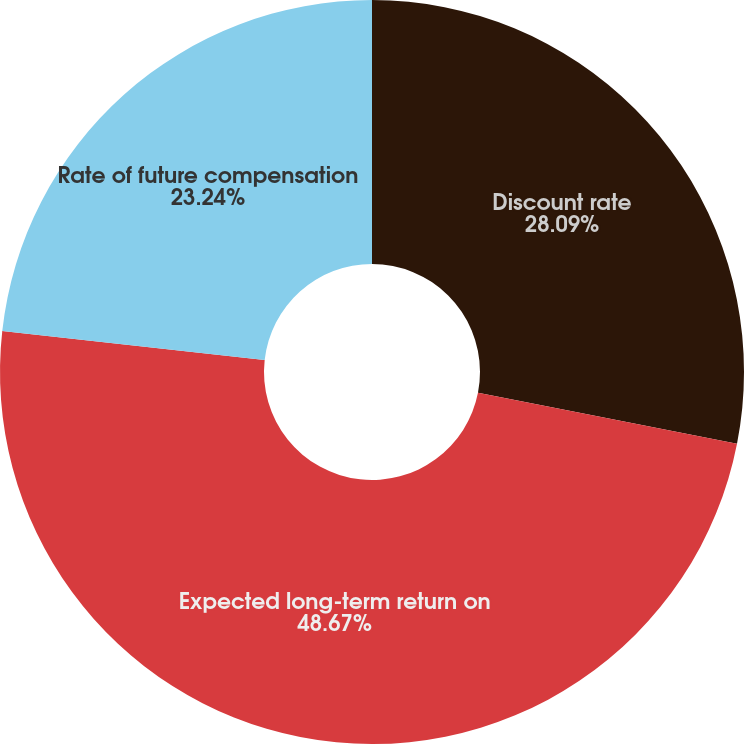<chart> <loc_0><loc_0><loc_500><loc_500><pie_chart><fcel>Discount rate<fcel>Expected long-term return on<fcel>Rate of future compensation<nl><fcel>28.09%<fcel>48.67%<fcel>23.24%<nl></chart> 